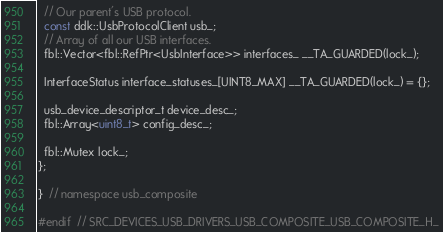<code> <loc_0><loc_0><loc_500><loc_500><_C_>
  // Our parent's USB protocol.
  const ddk::UsbProtocolClient usb_;
  // Array of all our USB interfaces.
  fbl::Vector<fbl::RefPtr<UsbInterface>> interfaces_ __TA_GUARDED(lock_);

  InterfaceStatus interface_statuses_[UINT8_MAX] __TA_GUARDED(lock_) = {};

  usb_device_descriptor_t device_desc_;
  fbl::Array<uint8_t> config_desc_;

  fbl::Mutex lock_;
};

}  // namespace usb_composite

#endif  // SRC_DEVICES_USB_DRIVERS_USB_COMPOSITE_USB_COMPOSITE_H_
</code> 